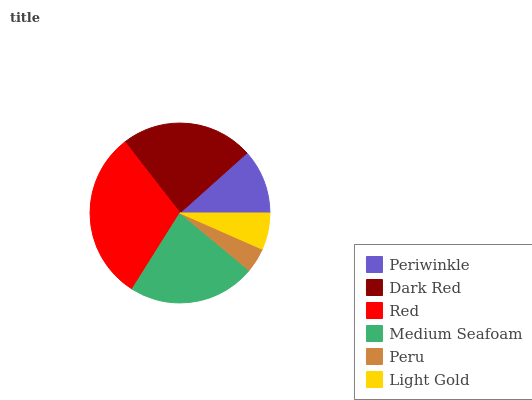Is Peru the minimum?
Answer yes or no. Yes. Is Red the maximum?
Answer yes or no. Yes. Is Dark Red the minimum?
Answer yes or no. No. Is Dark Red the maximum?
Answer yes or no. No. Is Dark Red greater than Periwinkle?
Answer yes or no. Yes. Is Periwinkle less than Dark Red?
Answer yes or no. Yes. Is Periwinkle greater than Dark Red?
Answer yes or no. No. Is Dark Red less than Periwinkle?
Answer yes or no. No. Is Medium Seafoam the high median?
Answer yes or no. Yes. Is Periwinkle the low median?
Answer yes or no. Yes. Is Dark Red the high median?
Answer yes or no. No. Is Medium Seafoam the low median?
Answer yes or no. No. 